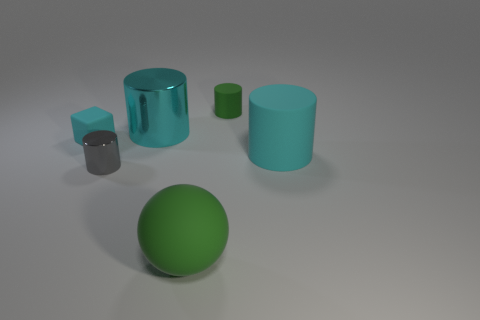What material is the small gray thing that is the same shape as the small green matte object?
Your response must be concise. Metal. The big rubber sphere is what color?
Your response must be concise. Green. What material is the other large cylinder that is the same color as the big rubber cylinder?
Offer a terse response. Metal. Is there a blue object that has the same shape as the small cyan object?
Make the answer very short. No. There is a cyan matte object that is on the left side of the green matte cylinder; what is its size?
Give a very brief answer. Small. There is a gray cylinder that is the same size as the green cylinder; what is it made of?
Offer a terse response. Metal. Are there more cyan objects than tiny matte objects?
Give a very brief answer. Yes. How big is the gray cylinder that is to the left of the green matte thing that is behind the ball?
Offer a very short reply. Small. There is a cyan shiny thing that is the same size as the cyan rubber cylinder; what is its shape?
Your answer should be very brief. Cylinder. What is the shape of the big rubber thing behind the cylinder to the left of the big cylinder that is left of the large sphere?
Ensure brevity in your answer.  Cylinder. 